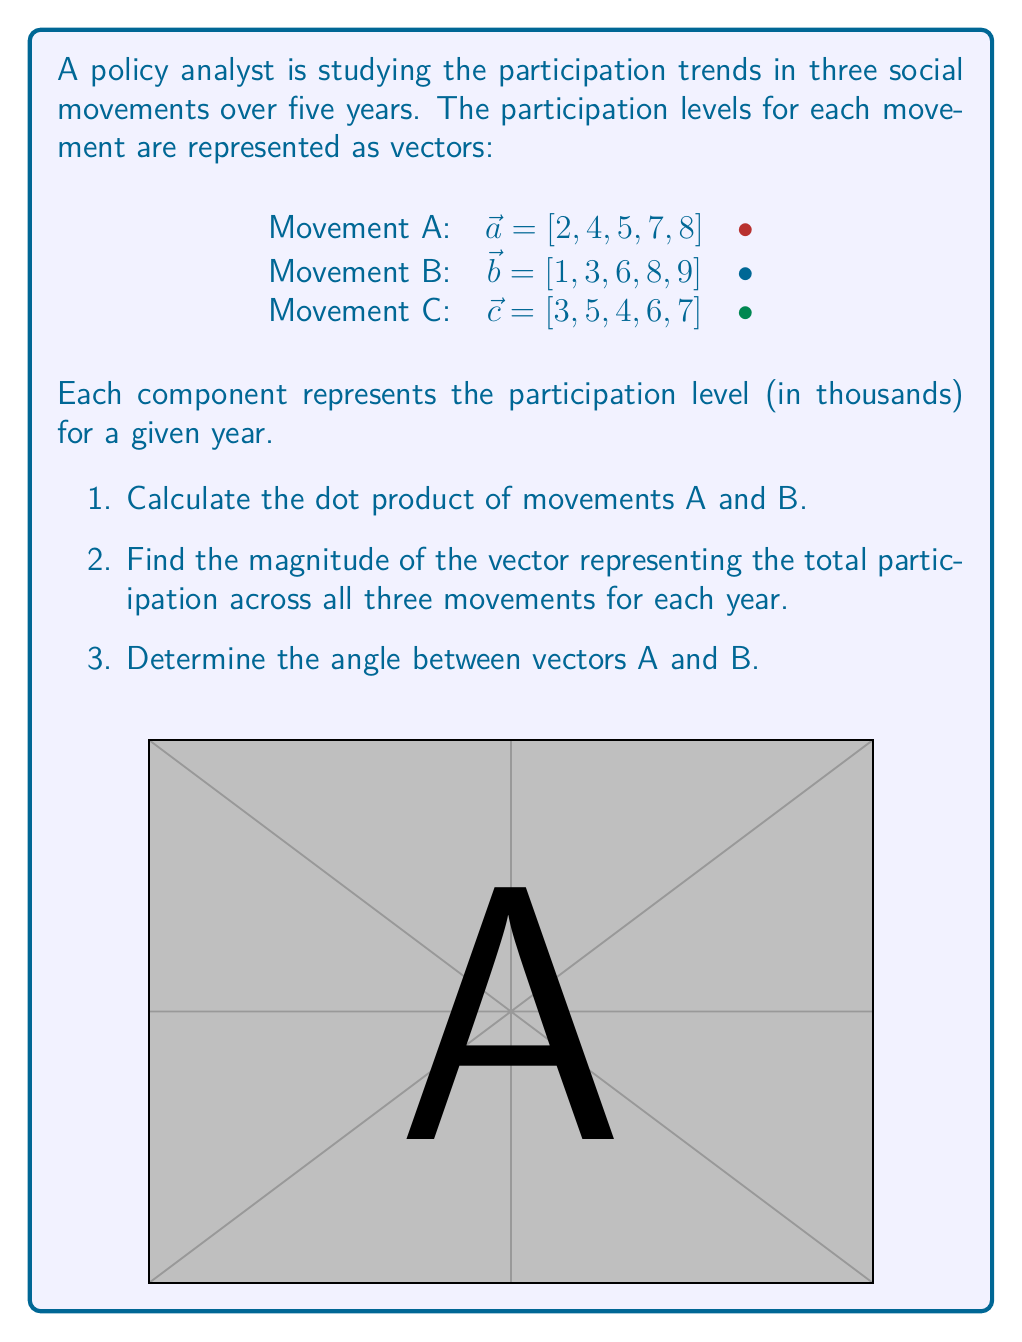What is the answer to this math problem? Let's solve this problem step by step:

1. Dot product of movements A and B:
   $$\vec{a} \cdot \vec{b} = (2)(1) + (4)(3) + (5)(6) + (7)(8) + (8)(9)$$
   $$= 2 + 12 + 30 + 56 + 72 = 172$$

2. To find the magnitude of the total participation vector:
   First, we need to add the vectors:
   $$\vec{t} = \vec{a} + \vec{b} + \vec{c} = [2+1+3, 4+3+5, 5+6+4, 7+8+6, 8+9+7]$$
   $$\vec{t} = [6, 12, 15, 21, 24]$$
   
   Now, we calculate the magnitude:
   $$|\vec{t}| = \sqrt{6^2 + 12^2 + 15^2 + 21^2 + 24^2}$$
   $$= \sqrt{36 + 144 + 225 + 441 + 576}$$
   $$= \sqrt{1422} \approx 37.71$$

3. To find the angle between vectors A and B, we use the dot product formula:
   $$\cos \theta = \frac{\vec{a} \cdot \vec{b}}{|\vec{a}||\vec{b}|}$$
   
   We already calculated $\vec{a} \cdot \vec{b} = 172$
   
   Now we need $|\vec{a}|$ and $|\vec{b}|$:
   $$|\vec{a}| = \sqrt{2^2 + 4^2 + 5^2 + 7^2 + 8^2} = \sqrt{158} \approx 12.57$$
   $$|\vec{b}| = \sqrt{1^2 + 3^2 + 6^2 + 8^2 + 9^2} = \sqrt{203} \approx 14.25$$
   
   Substituting into the formula:
   $$\cos \theta = \frac{172}{(12.57)(14.25)} \approx 0.9597$$
   
   Taking the inverse cosine:
   $$\theta = \arccos(0.9597) \approx 0.2857 \text{ radians} \approx 16.37°$$
Answer: 1. 172
2. 37.71 (thousand)
3. 16.37° 